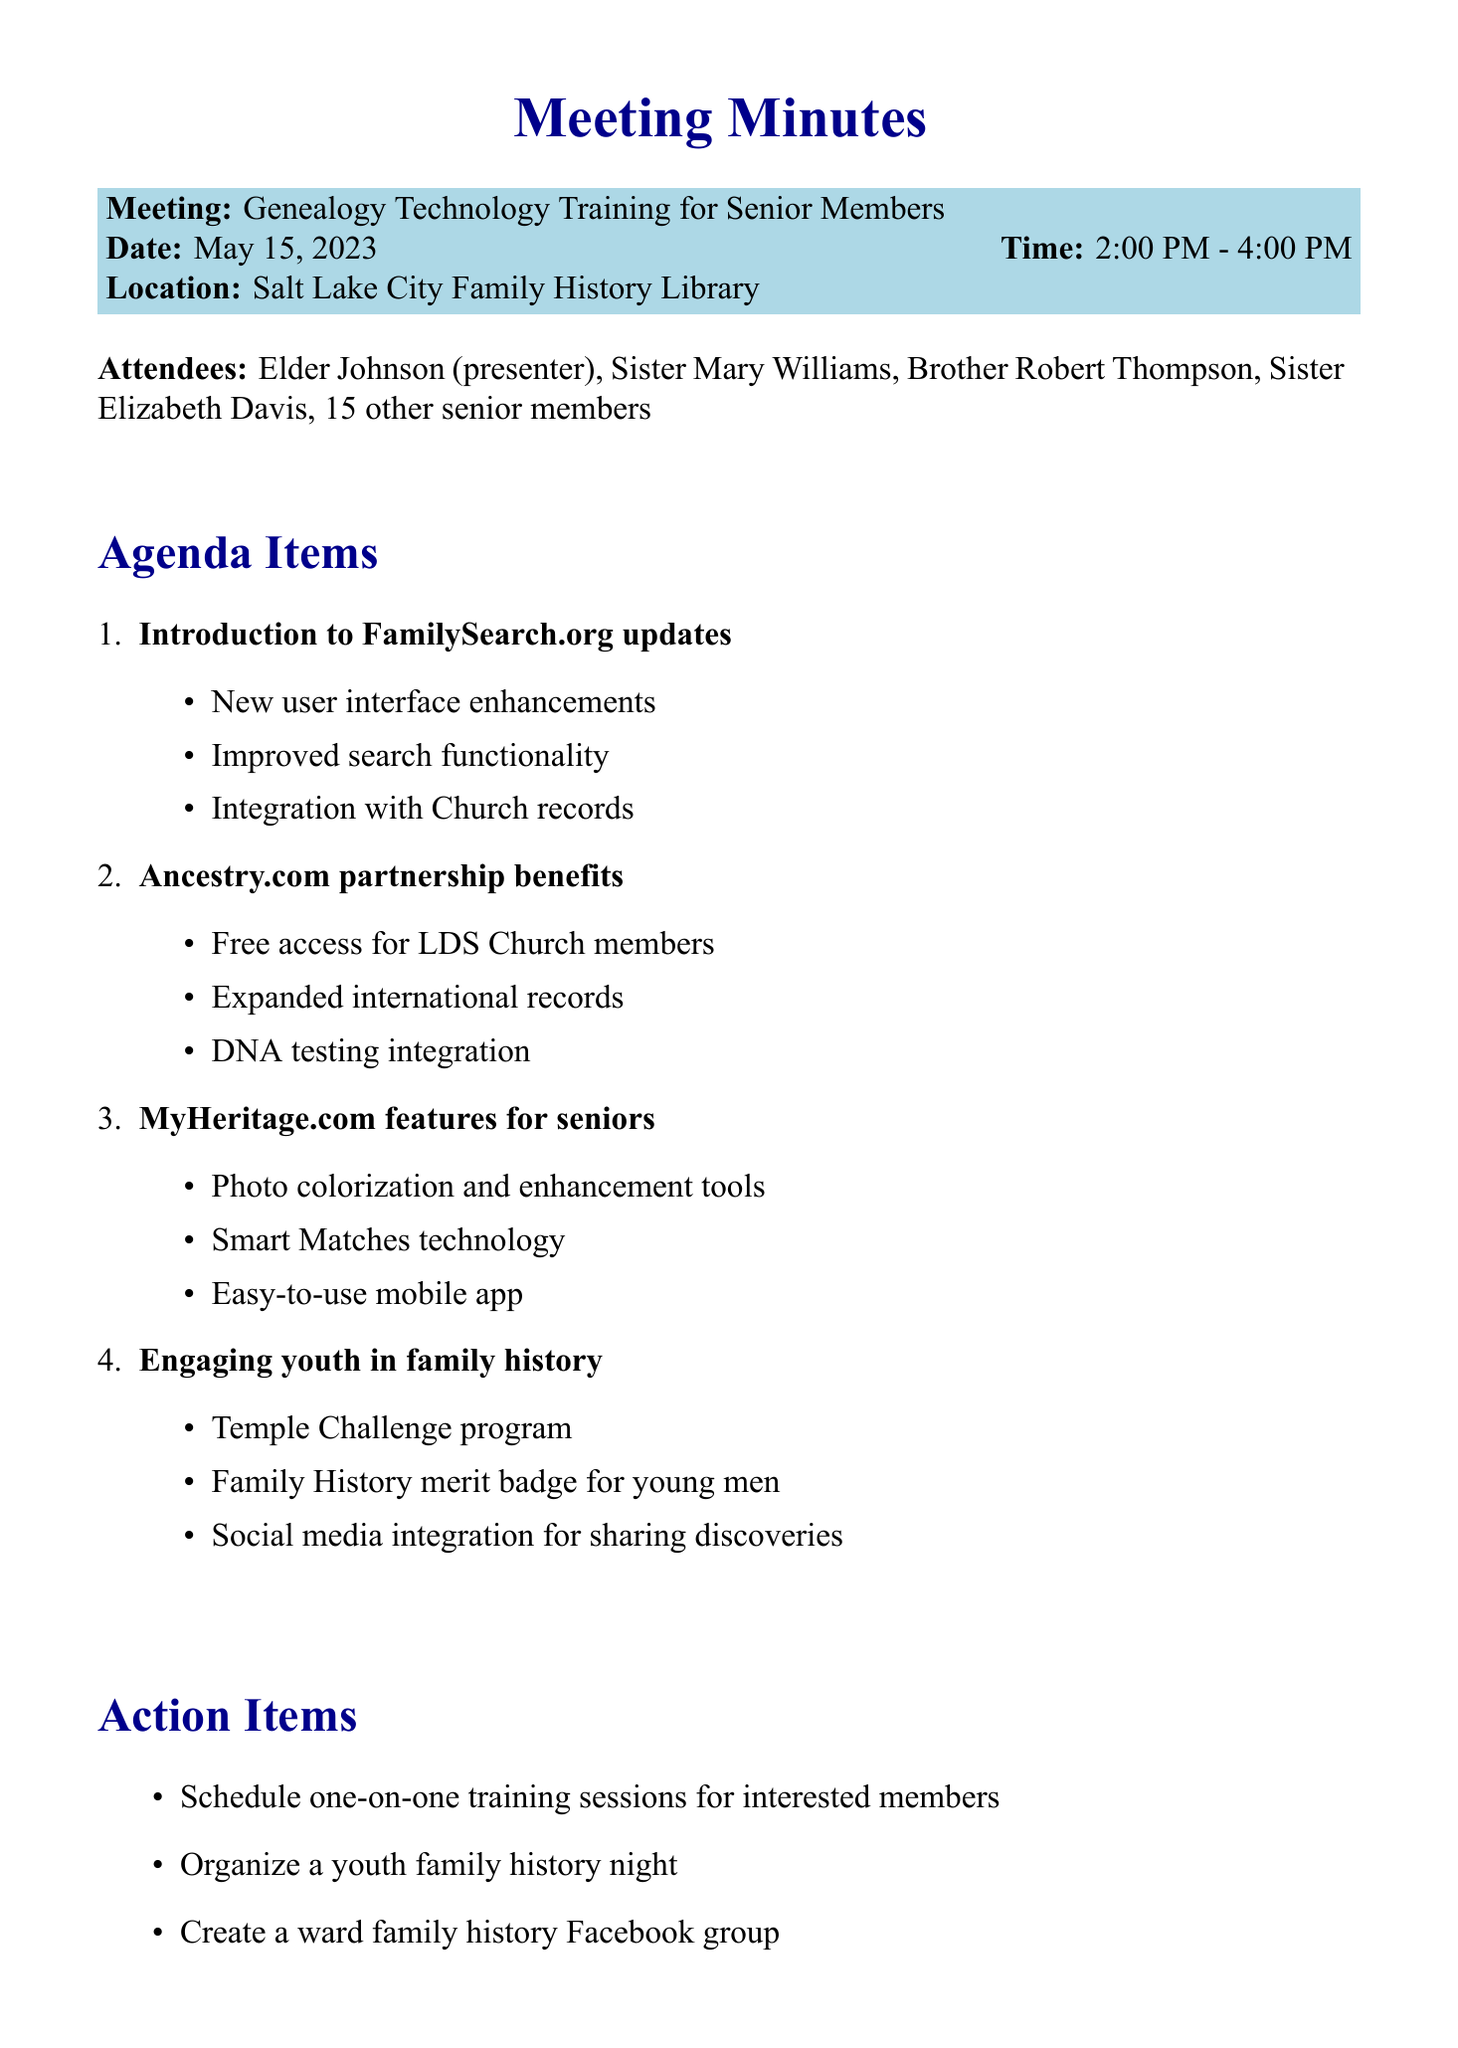What is the title of the meeting? The title of the meeting is stated at the beginning of the document.
Answer: Genealogy Technology Training for Senior Members What date was the meeting held? The date of the meeting is listed under the meeting details.
Answer: May 15, 2023 Who presented the session? The presenter's name is included in the attendee list at the beginning of the document.
Answer: Elder Johnson What are the key points discussed under MyHeritage.com features? The document details key points for each agenda item, including MyHeritage.com features.
Answer: Photo colorization and enhancement tools, Smart Matches technology, Easy-to-use mobile app How many senior members attended the session? The number of attendees is included in the attendee section of the document.
Answer: 15 other senior members What action item involves social media? The action items listed include specific tasks to be completed after the meeting.
Answer: Create a ward family history Facebook group What program engages youth in family history? The document highlights specific programs aimed at engaging youth in family history.
Answer: Temple Challenge program What was the time duration of the meeting? The time of the meeting is stated explicitly in the meeting details section.
Answer: 2:00 PM - 4:00 PM What is the closing remark's message? The closing remarks provide an inspirational message related to the purpose of the meeting.
Answer: Remember, every soul discovered is a potential temple ordinance 